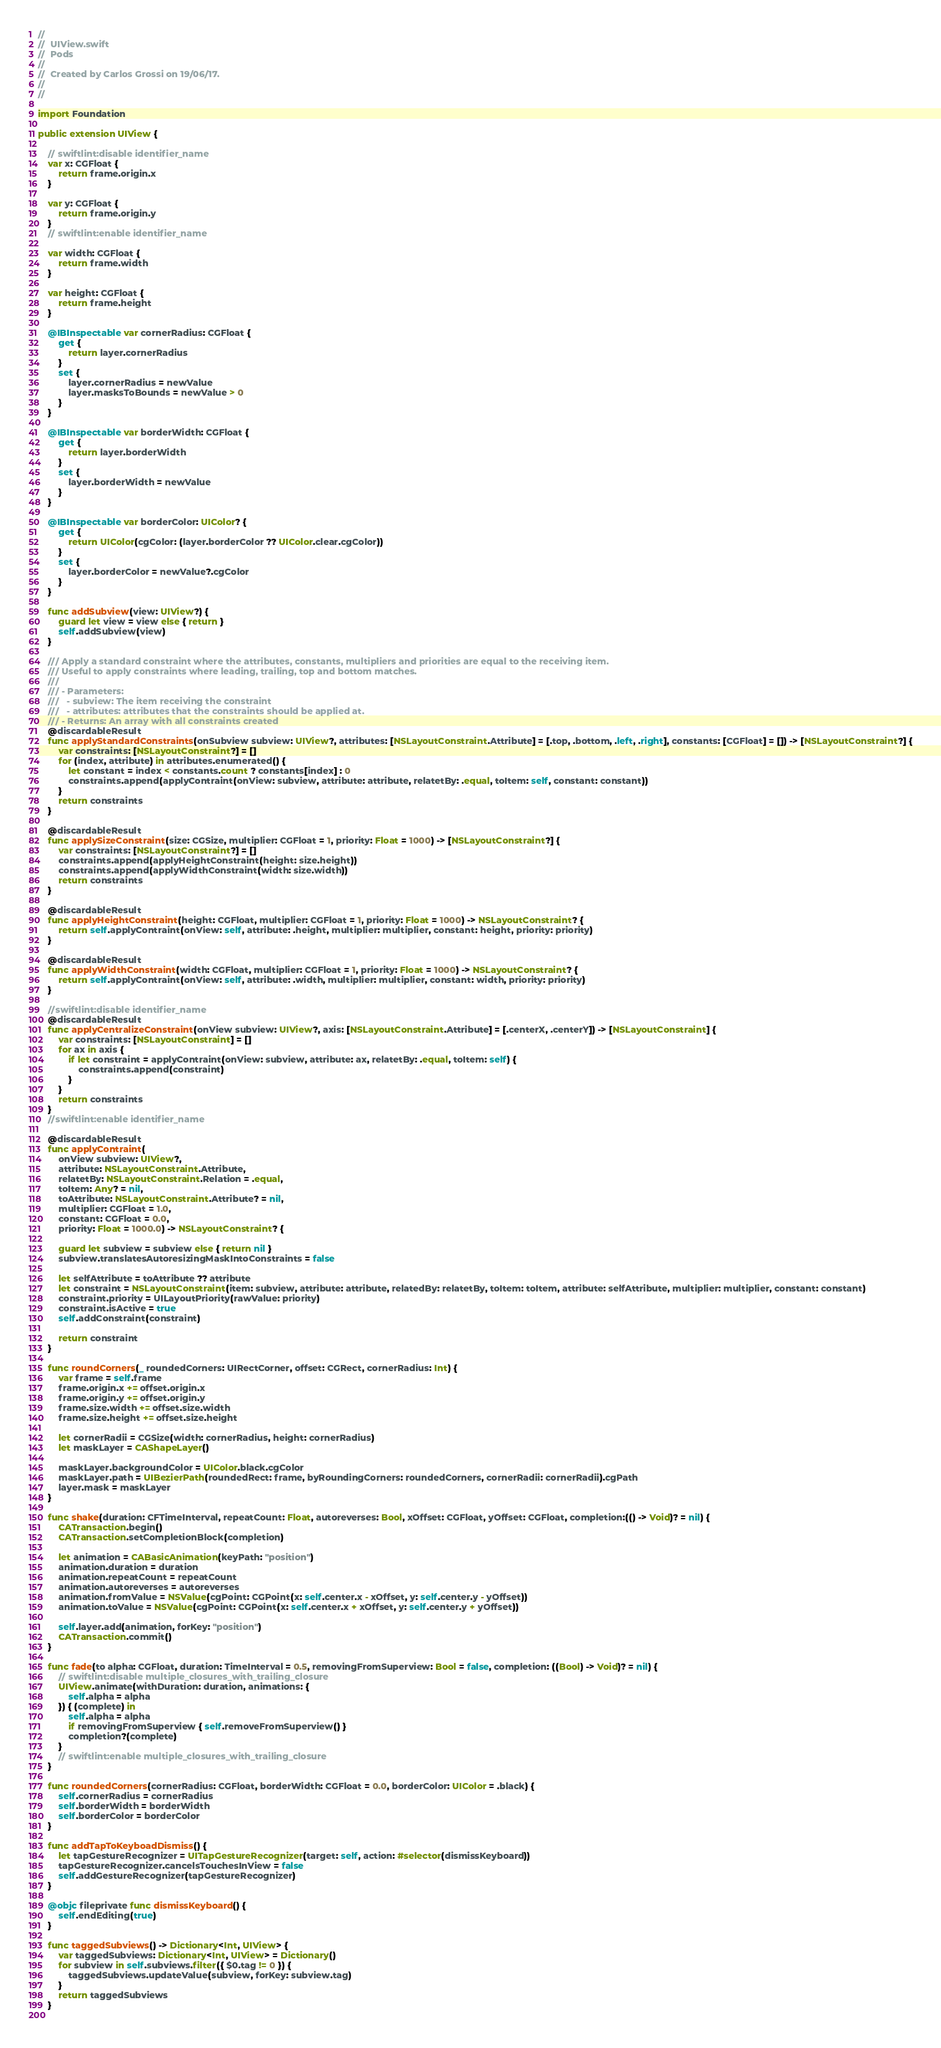Convert code to text. <code><loc_0><loc_0><loc_500><loc_500><_Swift_>//
//  UIView.swift
//  Pods
//
//  Created by Carlos Grossi on 19/06/17.
//
//

import Foundation

public extension UIView {
	
    // swiftlint:disable identifier_name
	var x: CGFloat {
        return frame.origin.x
	}
	
	var y: CGFloat {
		return frame.origin.y
	}
    // swiftlint:enable identifier_name
	
	var width: CGFloat {
		return frame.width
	}
	
	var height: CGFloat {
		return frame.height
	}
	
	@IBInspectable var cornerRadius: CGFloat {
		get {
			return layer.cornerRadius
		}
		set {
			layer.cornerRadius = newValue
			layer.masksToBounds = newValue > 0
		}
	}
	
	@IBInspectable var borderWidth: CGFloat {
		get {
			return layer.borderWidth
		}
		set {
			layer.borderWidth = newValue
		}
	}
	
	@IBInspectable var borderColor: UIColor? {
		get {
			return UIColor(cgColor: (layer.borderColor ?? UIColor.clear.cgColor))
		}
		set {
			layer.borderColor = newValue?.cgColor
		}
	}
	
	func addSubview(view: UIView?) {
		guard let view = view else { return }
		self.addSubview(view)
	}
	
	/// Apply a standard constraint where the attributes, constants, multipliers and priorities are equal to the receiving item. 
	/// Useful to apply constraints where leading, trailing, top and bottom matches.
	///
	/// - Parameters:
	///   - subview: The item receiving the constraint
	///   - attributes: attributes that the constraints should be applied at.
	/// - Returns: An array with all constraints created
    @discardableResult
	func applyStandardConstraints(onSubview subview: UIView?, attributes: [NSLayoutConstraint.Attribute] = [.top, .bottom, .left, .right], constants: [CGFloat] = []) -> [NSLayoutConstraint?] {
		var constraints: [NSLayoutConstraint?] = []
		for (index, attribute) in attributes.enumerated() {
			let constant = index < constants.count ? constants[index] : 0
			constraints.append(applyContraint(onView: subview, attribute: attribute, relatetBy: .equal, toItem: self, constant: constant))
		}
		return constraints
	}
	
    @discardableResult
	func applySizeConstraint(size: CGSize, multiplier: CGFloat = 1, priority: Float = 1000) -> [NSLayoutConstraint?] {
		var constraints: [NSLayoutConstraint?] = []
		constraints.append(applyHeightConstraint(height: size.height))
		constraints.append(applyWidthConstraint(width: size.width))
		return constraints
	}
	
    @discardableResult
	func applyHeightConstraint(height: CGFloat, multiplier: CGFloat = 1, priority: Float = 1000) -> NSLayoutConstraint? {
		return self.applyContraint(onView: self, attribute: .height, multiplier: multiplier, constant: height, priority: priority)
	}
	
    @discardableResult
	func applyWidthConstraint(width: CGFloat, multiplier: CGFloat = 1, priority: Float = 1000) -> NSLayoutConstraint? {
		return self.applyContraint(onView: self, attribute: .width, multiplier: multiplier, constant: width, priority: priority)
	}
	
    //swiftlint:disable identifier_name
    @discardableResult
	func applyCentralizeConstraint(onView subview: UIView?, axis: [NSLayoutConstraint.Attribute] = [.centerX, .centerY]) -> [NSLayoutConstraint] {
		var constraints: [NSLayoutConstraint] = []
		for ax in axis {
			if let constraint = applyContraint(onView: subview, attribute: ax, relatetBy: .equal, toItem: self) {
				constraints.append(constraint)
			}
		}
		return constraints
	}
    //swiftlint:enable identifier_name
	
    @discardableResult
	func applyContraint(
        onView subview: UIView?,
        attribute: NSLayoutConstraint.Attribute,
        relatetBy: NSLayoutConstraint.Relation = .equal,
        toItem: Any? = nil,
        toAttribute: NSLayoutConstraint.Attribute? = nil,
        multiplier: CGFloat = 1.0,
        constant: CGFloat = 0.0,
        priority: Float = 1000.0) -> NSLayoutConstraint? {
		
		guard let subview = subview else { return nil }
		subview.translatesAutoresizingMaskIntoConstraints = false
		
		let selfAttribute = toAttribute ?? attribute
		let constraint = NSLayoutConstraint(item: subview, attribute: attribute, relatedBy: relatetBy, toItem: toItem, attribute: selfAttribute, multiplier: multiplier, constant: constant)
        constraint.priority = UILayoutPriority(rawValue: priority)
		constraint.isActive = true
		self.addConstraint(constraint)
		
		return constraint
	}
	
	func roundCorners(_ roundedCorners: UIRectCorner, offset: CGRect, cornerRadius: Int) {
		var frame = self.frame
		frame.origin.x += offset.origin.x
		frame.origin.y += offset.origin.y
		frame.size.width += offset.size.width
		frame.size.height += offset.size.height
		
		let cornerRadii = CGSize(width: cornerRadius, height: cornerRadius)
		let maskLayer = CAShapeLayer()
		
		maskLayer.backgroundColor = UIColor.black.cgColor
		maskLayer.path = UIBezierPath(roundedRect: frame, byRoundingCorners: roundedCorners, cornerRadii: cornerRadii).cgPath
		layer.mask = maskLayer
	}
	
	func shake(duration: CFTimeInterval, repeatCount: Float, autoreverses: Bool, xOffset: CGFloat, yOffset: CGFloat, completion:(() -> Void)? = nil) {
		CATransaction.begin()
		CATransaction.setCompletionBlock(completion)
		
		let animation = CABasicAnimation(keyPath: "position")
		animation.duration = duration
		animation.repeatCount = repeatCount
		animation.autoreverses = autoreverses
		animation.fromValue = NSValue(cgPoint: CGPoint(x: self.center.x - xOffset, y: self.center.y - yOffset))
		animation.toValue = NSValue(cgPoint: CGPoint(x: self.center.x + xOffset, y: self.center.y + yOffset))
		
		self.layer.add(animation, forKey: "position")
		CATransaction.commit()
	}
	
	func fade(to alpha: CGFloat, duration: TimeInterval = 0.5, removingFromSuperview: Bool = false, completion: ((Bool) -> Void)? = nil) {
        // swiftlint:disable multiple_closures_with_trailing_closure
		UIView.animate(withDuration: duration, animations: {
			self.alpha = alpha
		}) { (complete) in
			self.alpha = alpha
			if removingFromSuperview { self.removeFromSuperview() }
			completion?(complete)
		}
        // swiftlint:enable multiple_closures_with_trailing_closure
	}
	
	func roundedCorners(cornerRadius: CGFloat, borderWidth: CGFloat = 0.0, borderColor: UIColor = .black) {
		self.cornerRadius = cornerRadius
		self.borderWidth = borderWidth
		self.borderColor = borderColor
	}
	
	func addTapToKeyboadDismiss() {
		let tapGestureRecognizer = UITapGestureRecognizer(target: self, action: #selector(dismissKeyboard))
		tapGestureRecognizer.cancelsTouchesInView = false
		self.addGestureRecognizer(tapGestureRecognizer)
	}
	
	@objc fileprivate func dismissKeyboard() {
		self.endEditing(true)
	}
	
    func taggedSubviews() -> Dictionary<Int, UIView> {
        var taggedSubviews: Dictionary<Int, UIView> = Dictionary()
        for subview in self.subviews.filter({ $0.tag != 0 }) {
            taggedSubviews.updateValue(subview, forKey: subview.tag)
        }
        return taggedSubviews
    }
    </code> 